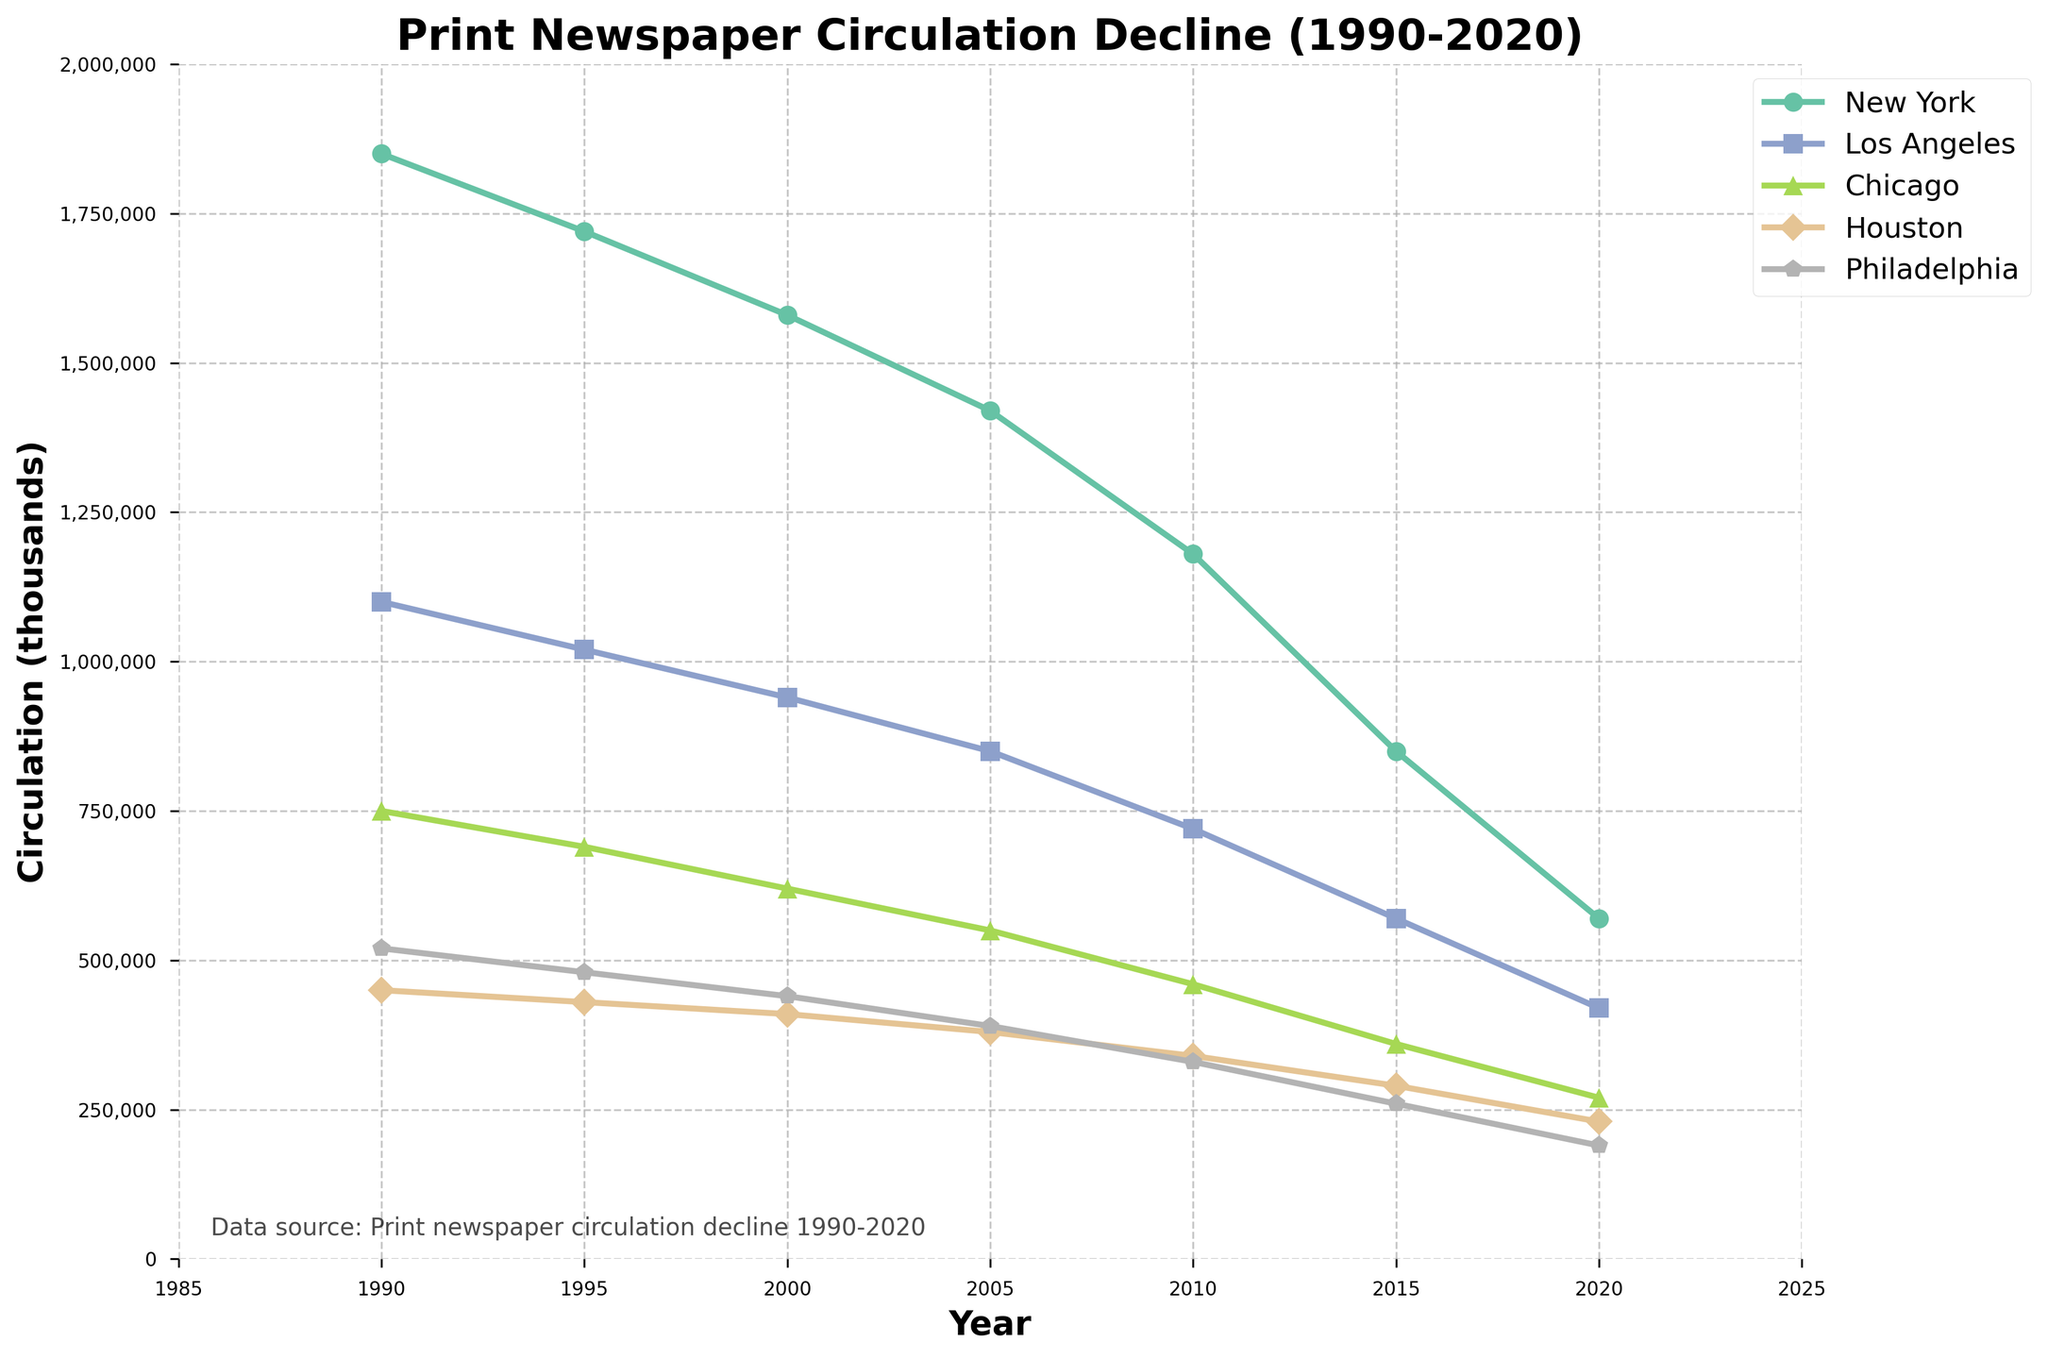What is the circulation difference between New York and Houston in 2020? In 2020, New York's circulation is 570,000 and Houston's is 230,000. Subtract Houston's circulation from New York's: 570,000 - 230,000
Answer: 340,000 Which city had the highest circulation in 1995? Look for the highest value in the circulation data for 1995 across the cities. New York had the highest circulation with 1,720,000 copies.
Answer: New York How does the circulation of Philadelphia in 2010 compare to its circulation in 2000? In 2010, Philadelphia's circulation is 330,000, and in 2000, it is 440,000. Comparing the two values, 330,000 is less than 440,000.
Answer: Less than What is the average circulation for Chicago across all years provided? Add Chicago's yearly circulation values: (750,000 + 690,000 + 620,000 + 550,000 + 460,000 + 360,000 + 270,000) = 3,700,000. Divide by the number of years (7): 3,700,000 / 7
Answer: 528,571 Between which consecutive years did New York see the greatest decline in circulation? Calculate the year-over-year decline for New York:
- From 1990 to 1995: 1850k - 1720k = 130k
- From 1995 to 2000: 1720k - 1580k = 140k
- From 2000 to 2005: 1580k - 1420k = 160k
- From 2005 to 2010: 1420k - 1180k = 240k
- From 2010 to 2015: 1180k - 850k = 330k
- From 2015 to 2020: 850k - 570k = 280k
The greatest decline occurred between 2010 and 2015.
Answer: 2010 to 2015 Which city had the steepest decline in circulation from 1990 to 2020? Consider the decline in circulation for each city from 1990 to 2020:
- New York: 1850k - 570k = 1280k
- Los Angeles: 1100k - 420k = 680k
- Chicago: 750k - 270k = 480k
- Houston: 450k - 230k = 220k
- Philadelphia: 520k - 190k = 330k
New York had the steepest decline.
Answer: New York By how much did circulation in Los Angeles decrease from 2005 to 2015? In 2005, Los Angeles' circulation is 850,000, and in 2015, it is 570,000. Subtract the 2015 circulation from the 2005 circulation: 850,000 - 570,000
Answer: 280,000 What trend can be observed in the circulation data for all cities from 1990 to 2020? The overall trend for all cities shows a consistent decline in circulation over the 30 years. This indicates a general reduction in print newspaper readership in major US cities during that period.
Answer: Consistent decline Out of the years provided, during which year did Houston's circulation drop below 400,000? Analyze Houston's circulation data for each year:
- 1990: 450,000 (above 400,000)
- 1995: 430,000 (above 400,000)
- 2000: 410,000 (above 400,000)
- 2005: 380,000 (below 400,000)
Houston's circulation dropped below 400,000 in 2005.
Answer: 2005 